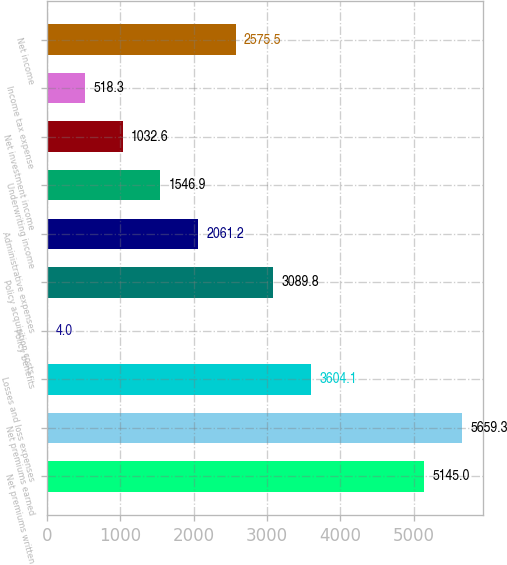Convert chart. <chart><loc_0><loc_0><loc_500><loc_500><bar_chart><fcel>Net premiums written<fcel>Net premiums earned<fcel>Losses and loss expenses<fcel>Policy benefits<fcel>Policy acquisition costs<fcel>Administrative expenses<fcel>Underwriting income<fcel>Net investment income<fcel>Income tax expense<fcel>Net income<nl><fcel>5145<fcel>5659.3<fcel>3604.1<fcel>4<fcel>3089.8<fcel>2061.2<fcel>1546.9<fcel>1032.6<fcel>518.3<fcel>2575.5<nl></chart> 